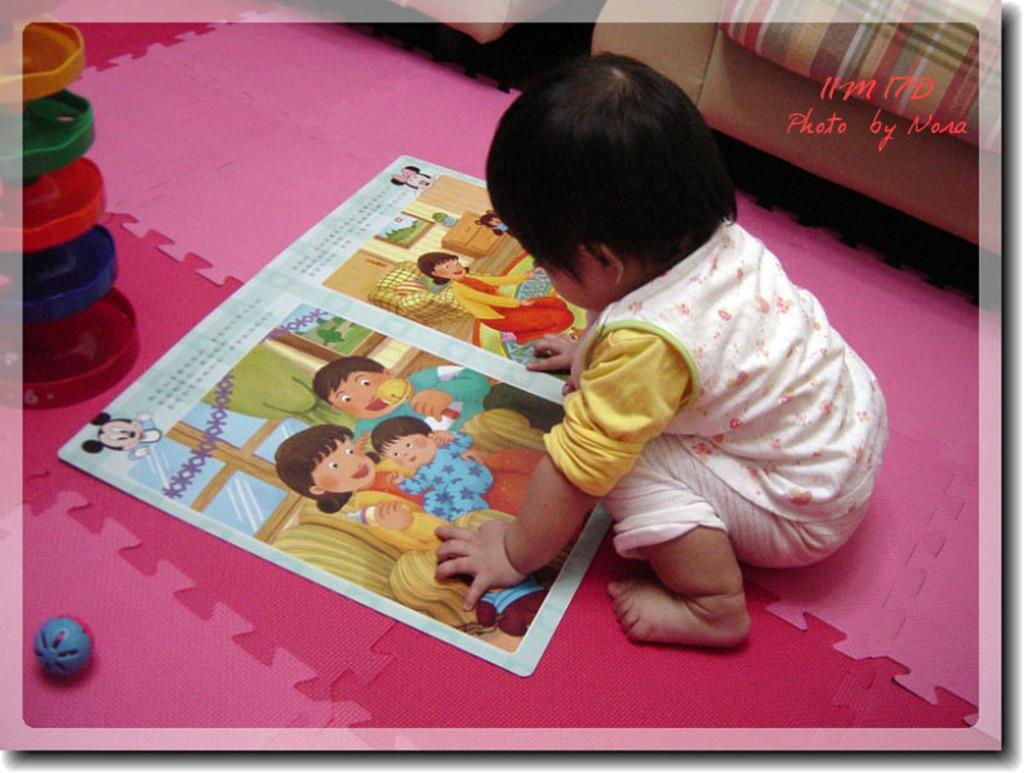Please provide a concise description of this image. In this picture we can see a child, book, ball and a toy on the floor and in the background we can see chairs. 